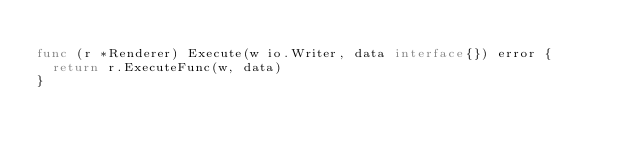Convert code to text. <code><loc_0><loc_0><loc_500><loc_500><_Go_>
func (r *Renderer) Execute(w io.Writer, data interface{}) error {
	return r.ExecuteFunc(w, data)
}
</code> 